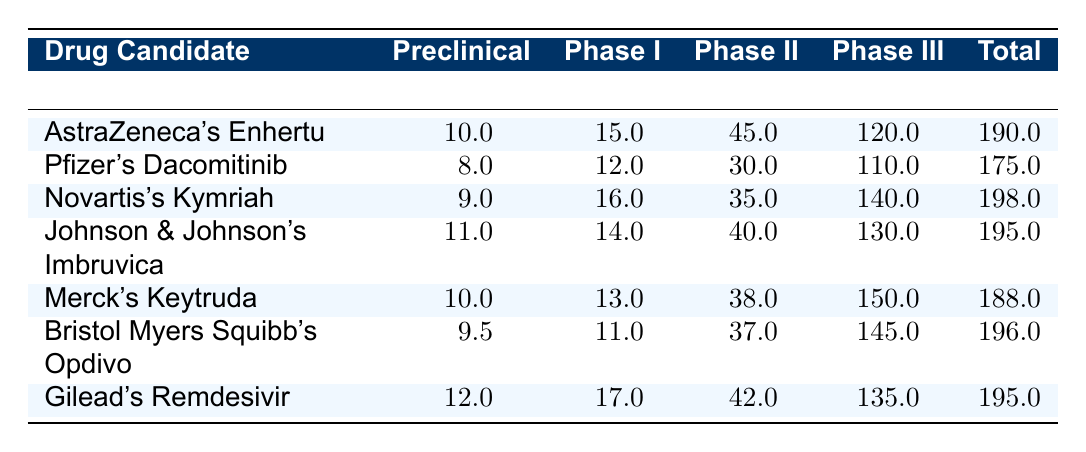What is the total expenditure for Novartis's Kymriah? To find the total expenditure for Novartis's Kymriah, we refer to the table and see that the value listed under Total Expenditure is 198.0 million USD.
Answer: 198.0 million USD Which drug candidate had the highest Phase III expenditure? By examining the Phase III expenditure column, we find that Novartis's Kymriah has the highest value at 140.0 million USD.
Answer: Novartis's Kymriah What is the difference in expenditure between Phase I and Phase II for Bristol Myers Squibb's Opdivo? The expenditures for Phase I and II are 11.0 million USD and 37.0 million USD respectively. The difference is calculated as 37.0 - 11.0 = 26.0 million USD.
Answer: 26.0 million USD Which drug candidate had the lowest total expenditure? Looking through the Total Expenditure column, Pfizer's Dacomitinib shows the lowest value at 175.0 million USD.
Answer: Pfizer's Dacomitinib What is the average expenditure for Preclinical among all drug candidates? Adding all Preclinical expenditures gives (10.0 + 8.0 + 9.0 + 11.0 + 10.0 + 9.5 + 12.0) = 69.5 million USD. Dividing by the number of drug candidates, which is 7, we get the average as 69.5 / 7 = 9.93 million USD.
Answer: 9.93 million USD Is Merck's Keytruda's total expenditure higher than 190 million USD? The total expenditure for Merck's Keytruda is 188.0 million USD. Since 188.0 million is less than 190.0 million, the answer is no.
Answer: No What percentage of the total expenditure for Gilead's Remdesivir is spent in Phase III? The total expenditure for Gilead's Remdesivir is 195.0 million USD, and the Phase III expenditure is 135.0 million USD. To find the percentage, we calculate (135.0 / 195.0) * 100 = 69.23%.
Answer: 69.23% Which two drug candidates have a total expenditure over 195 million USD? From the Total Expenditure column, we see that AstraZeneca's Enhertu (190.0) and Pfizer's Dacomitinib (175.0) do not exceed 195 million USD, while Novartis's Kymriah (198.0) and Bristol Myers Squibb's Opdivo (196.0) do. Thus, the two candidates are Novartis's Kymriah and Bristol Myers Squibb's Opdivo.
Answer: Novartis's Kymriah and Bristol Myers Squibb's Opdivo What is the sum of the expenditures in Phase I across all drug candidates? The expenditures in Phase I are (15.0 + 12.0 + 16.0 + 14.0 + 13.0 + 11.0 + 17.0) = 98.0 million USD. Therefore, the sum is 98.0 million USD.
Answer: 98.0 million USD How much more was spent in Phase III compared to Phase II for Merck's Keytruda? For Merck's Keytruda, the Phase III expenditure is 150.0 million USD, and the Phase II expenditure is 38.0 million USD. The difference is 150.0 - 38.0 = 112.0 million USD.
Answer: 112.0 million USD 